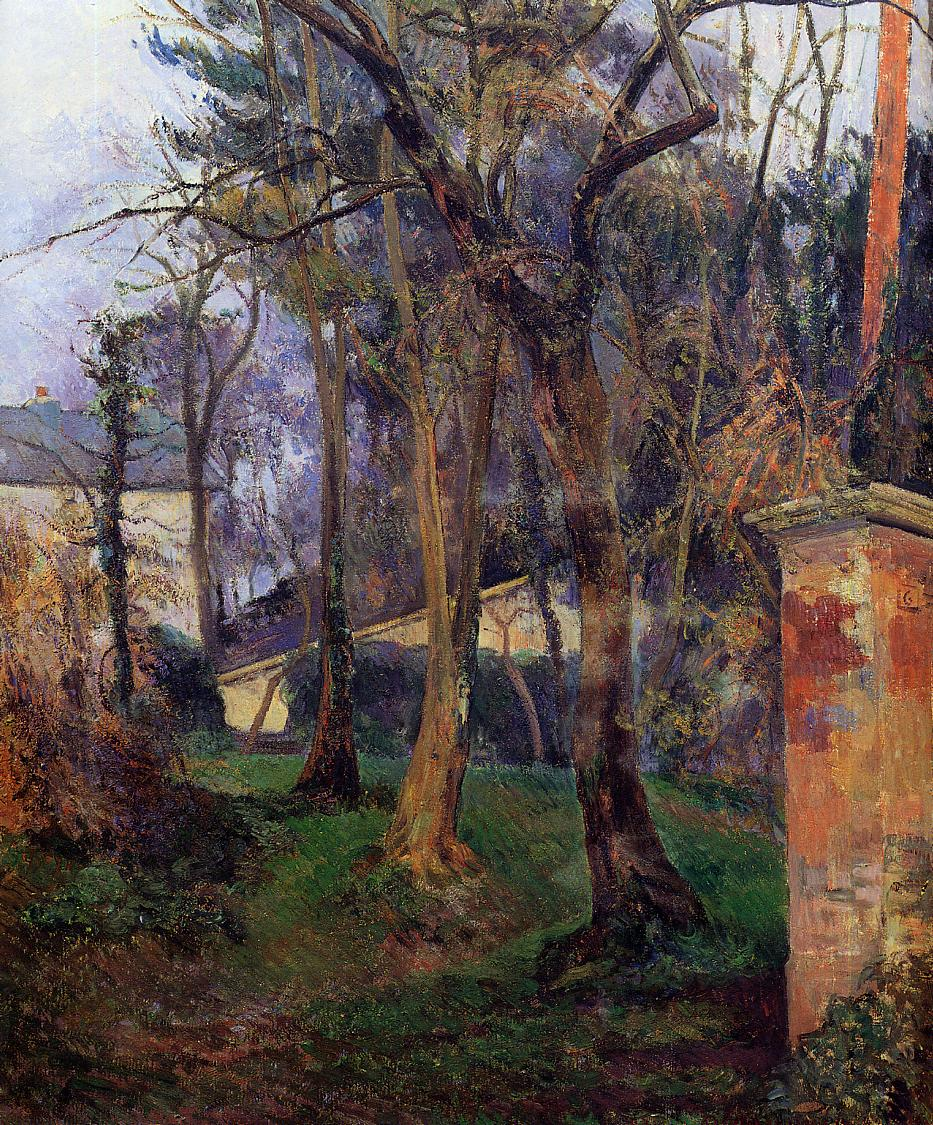What are the key elements in this picture? The image presents a beautiful example of impressionist painting, capturing a serene garden scene filled with lush elements. Dominant colors include various shades of green, blue, and brown, artfully used to depict the diverse landscape. At the forefront, the garden appears overgrown with an abundance of plants, creating a lush, vibrant atmosphere. Rising above the garden are tall trees with twisted trunks, their verdant foliage offering a stark contrast to the sky's blue hues. The loose, brushy art style typical of impressionism exquisitely plays with light and shadow, enhancing the scene's depth and dimension. In the background, partially hidden by the trees, is a house, subtly incorporating a human element into the otherwise natural setting. This artwork epitomizes impressionist landscape painting, beautifully capturing the tranquil and natural beauty of the garden. 